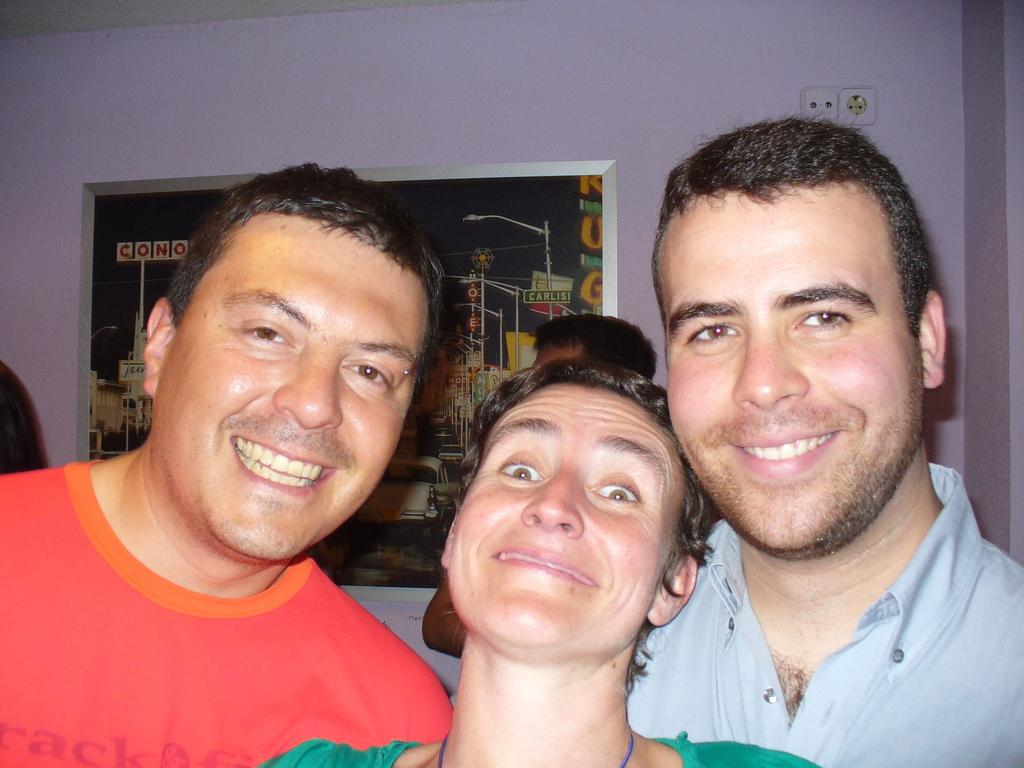Who or what is present in the image? There are people in the image. What can be seen on the wall in the image? There is a photo on the wall in the image. Where is the power socket located in the image? The power socket is on the right side of the image. What type of crow is perched on the power socket in the image? There is no crow present in the image; it only features people, a photo on the wall, and a power socket. 